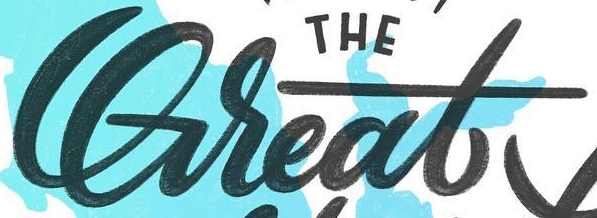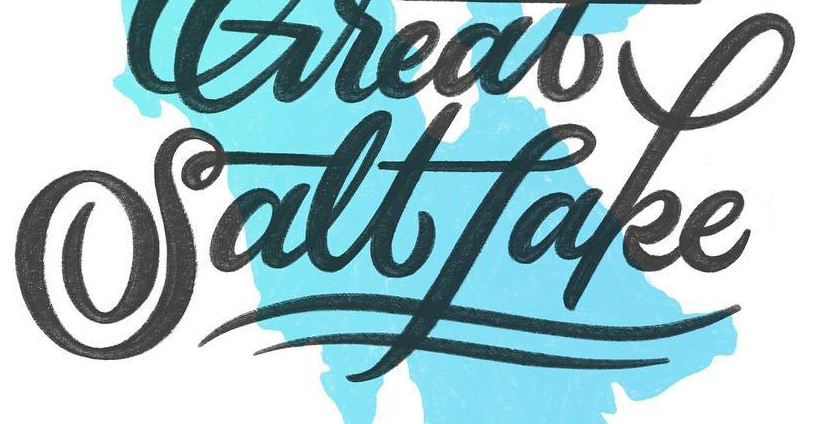What words are shown in these images in order, separated by a semicolon? Great; Saltfake 